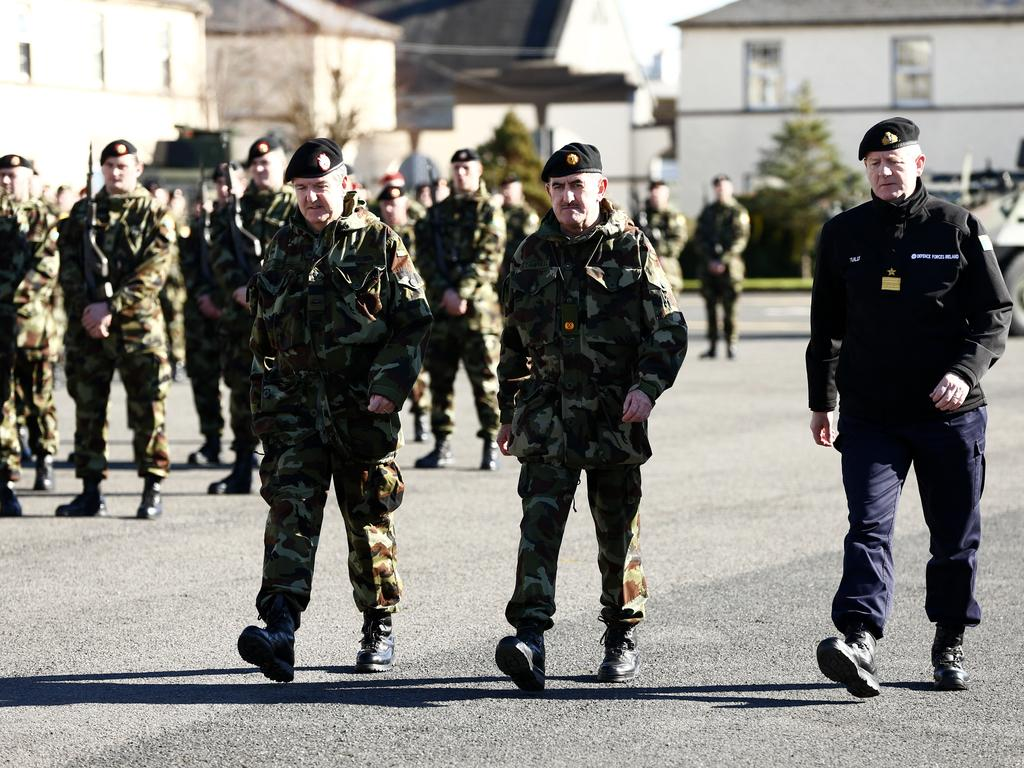How many people are walking in the image? There are three people walking in the image. What are the people on the path doing? The people standing on the path are not walking; they are stationary. What can be seen in the background of the image? There are trees and buildings visible in the background of the image. What type of chicken can be seen on the tongue of one of the people in the image? There is no chicken or tongue present in the image; it only features people walking and standing on a path. 